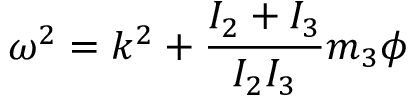<formula> <loc_0><loc_0><loc_500><loc_500>{ \boldsymbol \omega } ^ { 2 } = k ^ { 2 } + \frac { I _ { 2 } + I _ { 3 } } { I _ { 2 } I _ { 3 } } m _ { 3 } \phi</formula> 